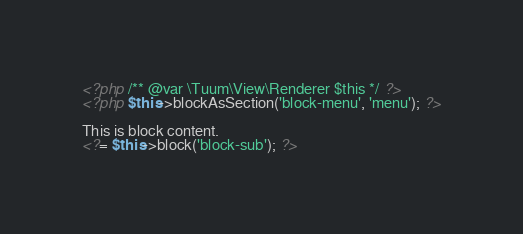Convert code to text. <code><loc_0><loc_0><loc_500><loc_500><_PHP_><?php /** @var \Tuum\View\Renderer $this */ ?>
<?php $this->blockAsSection('block-menu', 'menu'); ?>

This is block content.
<?= $this->block('block-sub'); ?>
</code> 